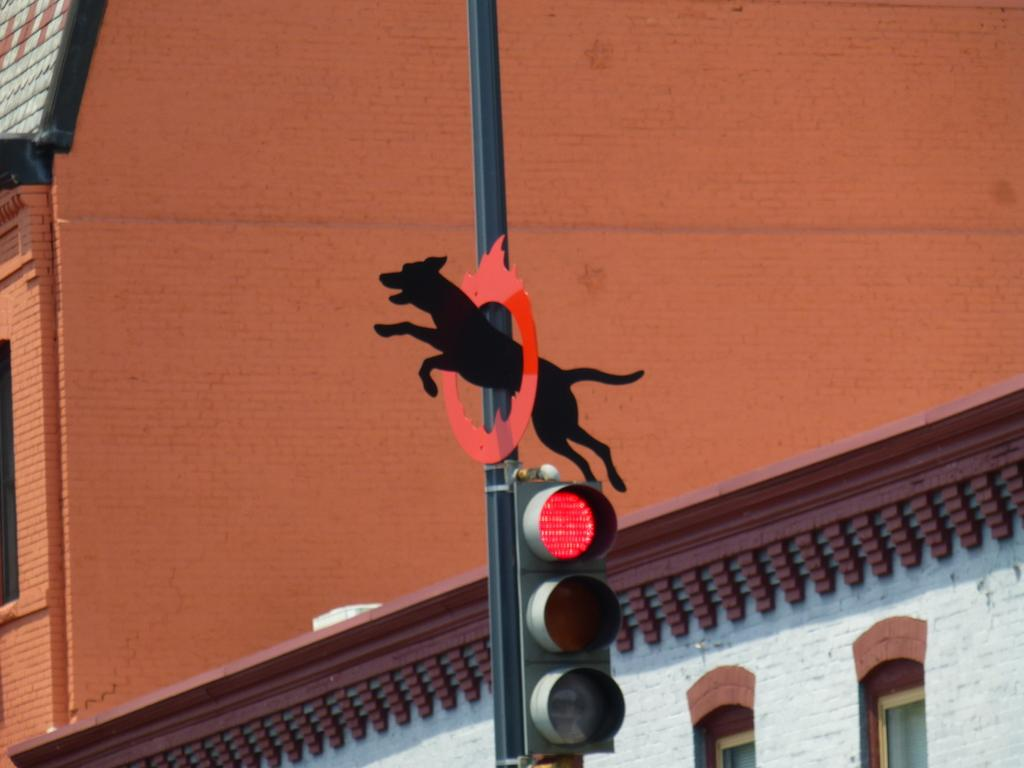What is located on the pole in the image? There is a traffic signal light and a board in the shape of a dog on the pole. What can be seen in the background of the image? There is a building with windows in the background. What type of airport can be seen in the image? There is no airport present in the image; it features a traffic signal light and a board in the shape of a dog on a pole, along with a building in the background. Is there any sleet visible in the image? There is no mention of sleet or any weather conditions in the provided facts, so it cannot be determined from the image. 